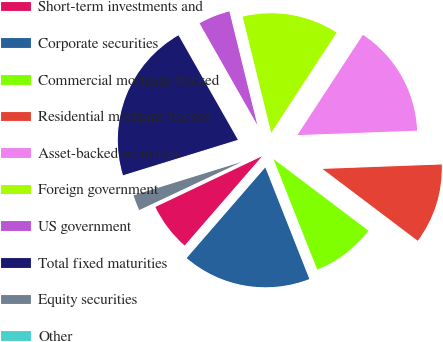Convert chart. <chart><loc_0><loc_0><loc_500><loc_500><pie_chart><fcel>Short-term investments and<fcel>Corporate securities<fcel>Commercial mortgage-backed<fcel>Residential mortgage-backed<fcel>Asset-backed securities<fcel>Foreign government<fcel>US government<fcel>Total fixed maturities<fcel>Equity securities<fcel>Other<nl><fcel>6.56%<fcel>17.36%<fcel>8.72%<fcel>10.88%<fcel>15.2%<fcel>13.04%<fcel>4.39%<fcel>21.54%<fcel>2.23%<fcel>0.07%<nl></chart> 